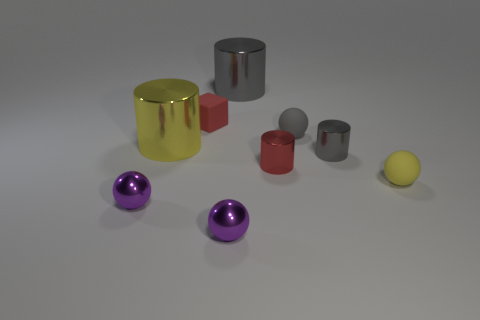Add 1 small cylinders. How many objects exist? 10 Subtract all yellow balls. How many balls are left? 3 Subtract all big gray cylinders. How many cylinders are left? 3 Subtract 2 cylinders. How many cylinders are left? 2 Add 4 tiny red metal cylinders. How many tiny red metal cylinders exist? 5 Subtract 0 yellow cubes. How many objects are left? 9 Subtract all cylinders. How many objects are left? 5 Subtract all gray cylinders. Subtract all yellow cubes. How many cylinders are left? 2 Subtract all green blocks. How many cyan spheres are left? 0 Subtract all big cyan metallic cylinders. Subtract all large shiny cylinders. How many objects are left? 7 